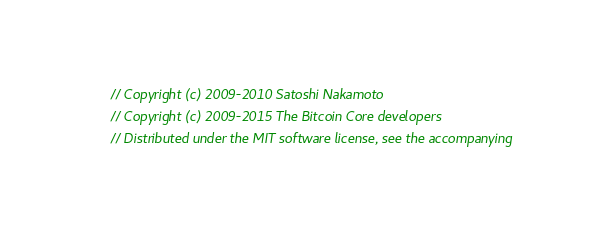Convert code to text. <code><loc_0><loc_0><loc_500><loc_500><_C++_>// Copyright (c) 2009-2010 Satoshi Nakamoto
// Copyright (c) 2009-2015 The Bitcoin Core developers
// Distributed under the MIT software license, see the accompanying</code> 